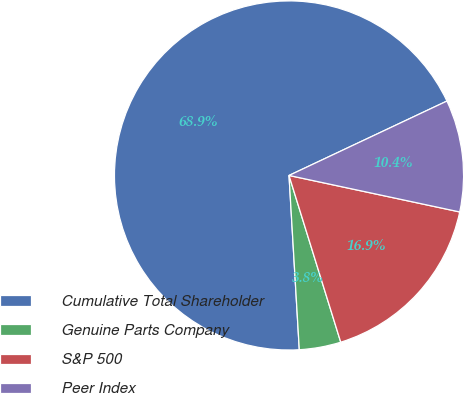Convert chart to OTSL. <chart><loc_0><loc_0><loc_500><loc_500><pie_chart><fcel>Cumulative Total Shareholder<fcel>Genuine Parts Company<fcel>S&P 500<fcel>Peer Index<nl><fcel>68.93%<fcel>3.85%<fcel>16.86%<fcel>10.36%<nl></chart> 